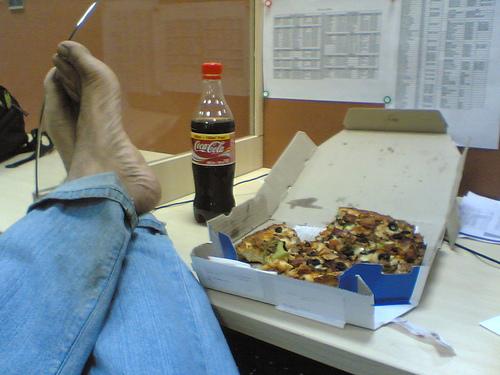Did the man order pizza?
Short answer required. Yes. What room are these books in?
Concise answer only. Office. What's in the box?
Concise answer only. Pizza. What is she eating?
Short answer required. Pizza. What race is the man?
Short answer required. Black. What is on the table?
Give a very brief answer. Pizza. What is in the box?
Give a very brief answer. Pizza. 